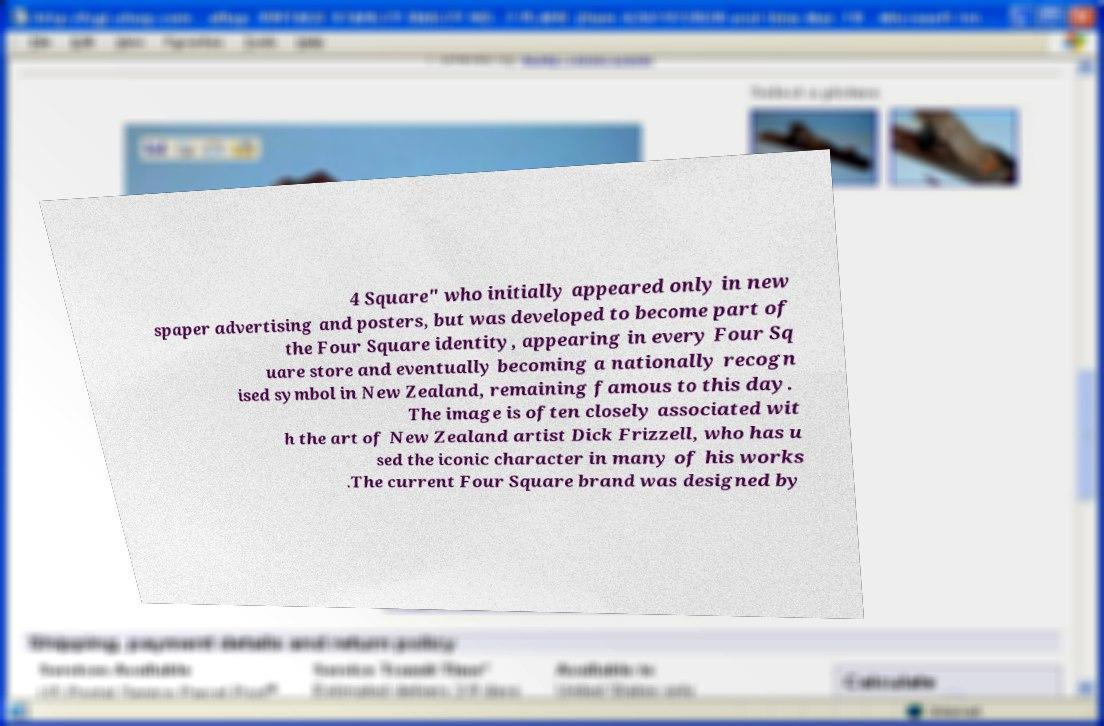What messages or text are displayed in this image? I need them in a readable, typed format. 4 Square" who initially appeared only in new spaper advertising and posters, but was developed to become part of the Four Square identity, appearing in every Four Sq uare store and eventually becoming a nationally recogn ised symbol in New Zealand, remaining famous to this day. The image is often closely associated wit h the art of New Zealand artist Dick Frizzell, who has u sed the iconic character in many of his works .The current Four Square brand was designed by 